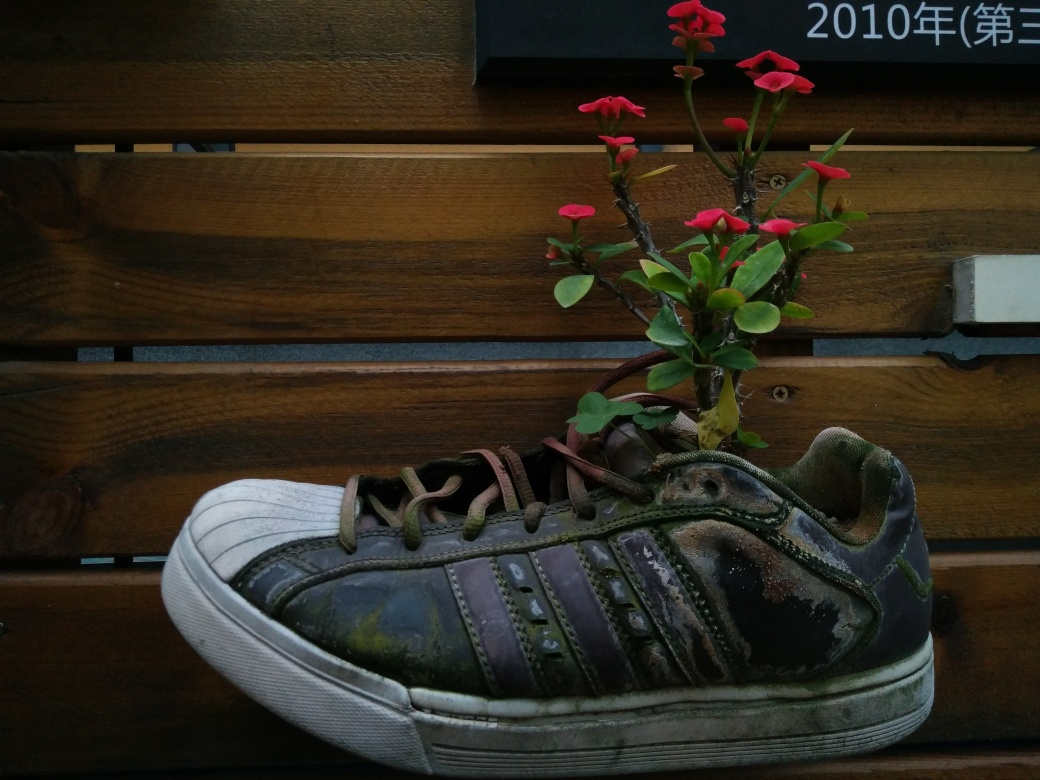What does this image tell us about the concept of reuse or repurposing objects? This image exemplifies the concept of repurposing by transforming an old, presumably discarded shoe into a makeshift plant pot. It conveys a message of sustainability and creativity, highlighting how everyday items can be given a new lease on life and purpose, challenging our throwaway culture. 